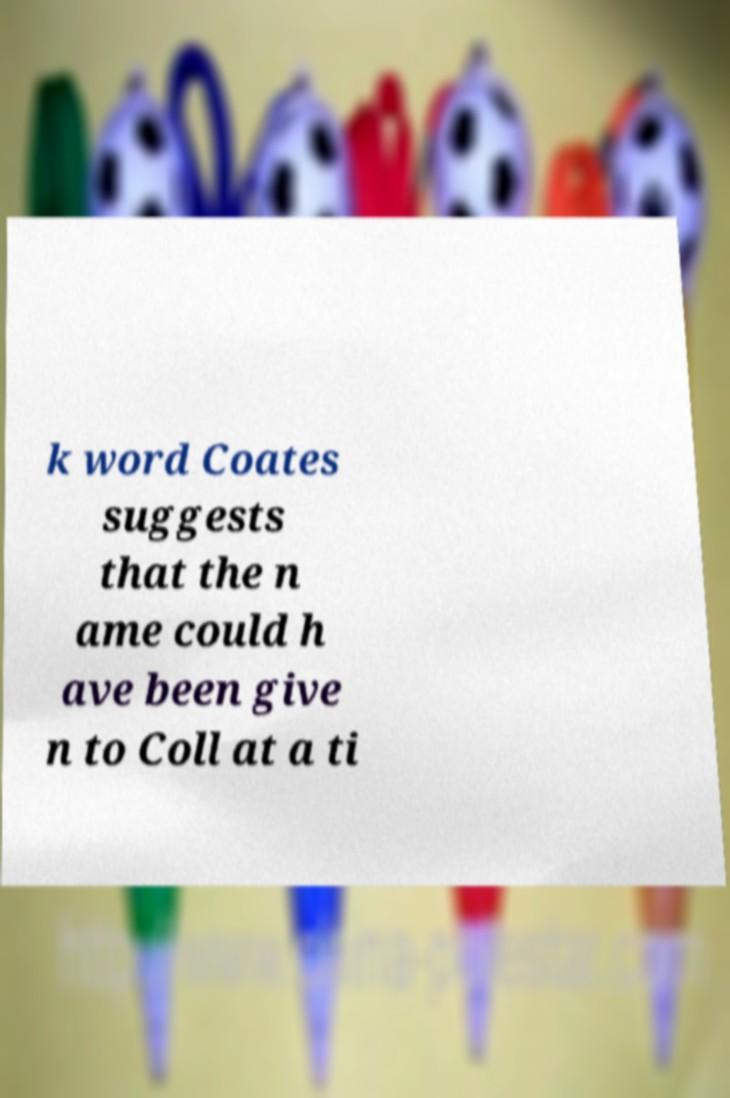Please identify and transcribe the text found in this image. k word Coates suggests that the n ame could h ave been give n to Coll at a ti 